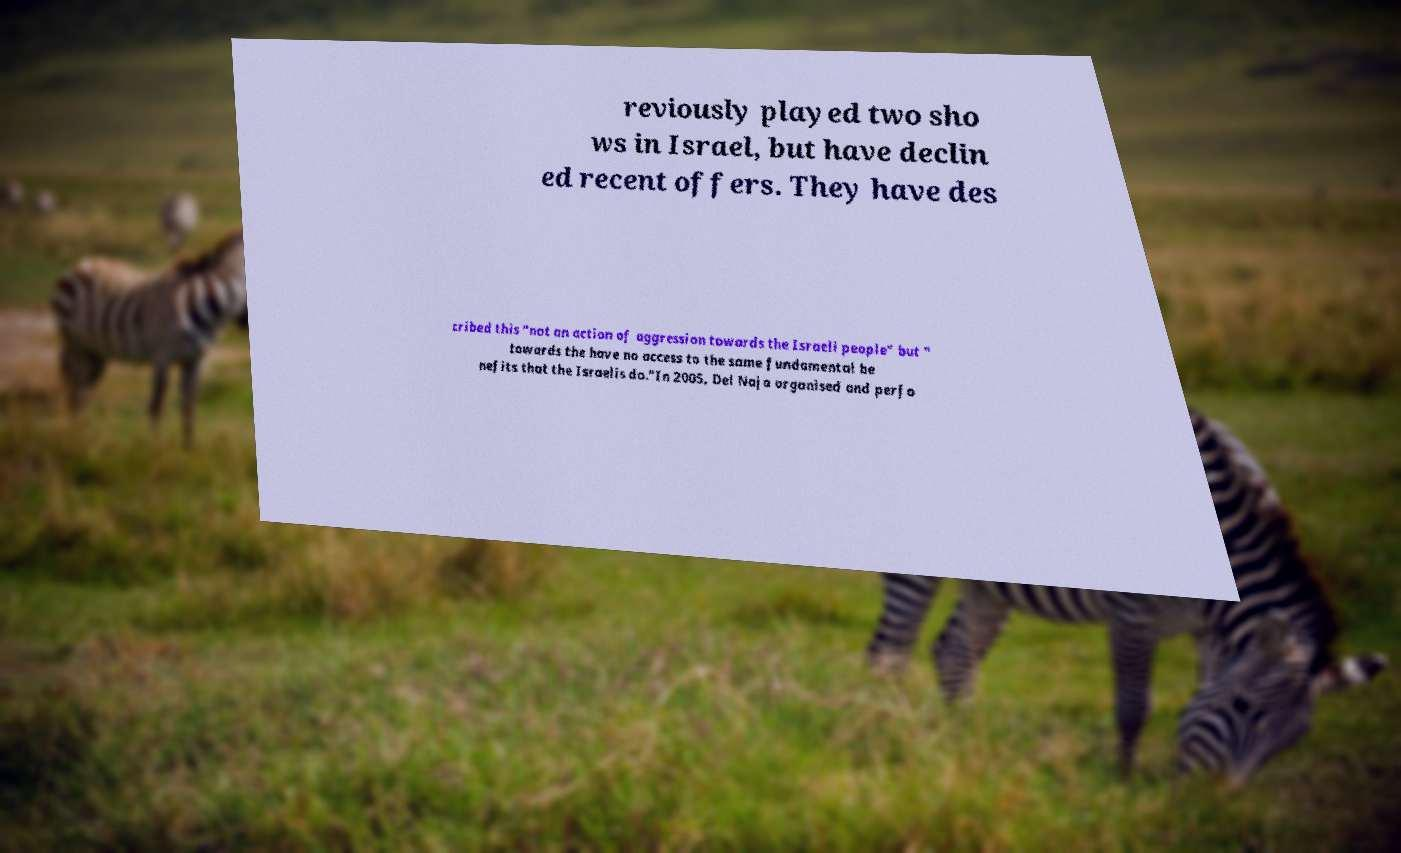What messages or text are displayed in this image? I need them in a readable, typed format. reviously played two sho ws in Israel, but have declin ed recent offers. They have des cribed this "not an action of aggression towards the Israeli people" but " towards the have no access to the same fundamental be nefits that the Israelis do."In 2005, Del Naja organised and perfo 